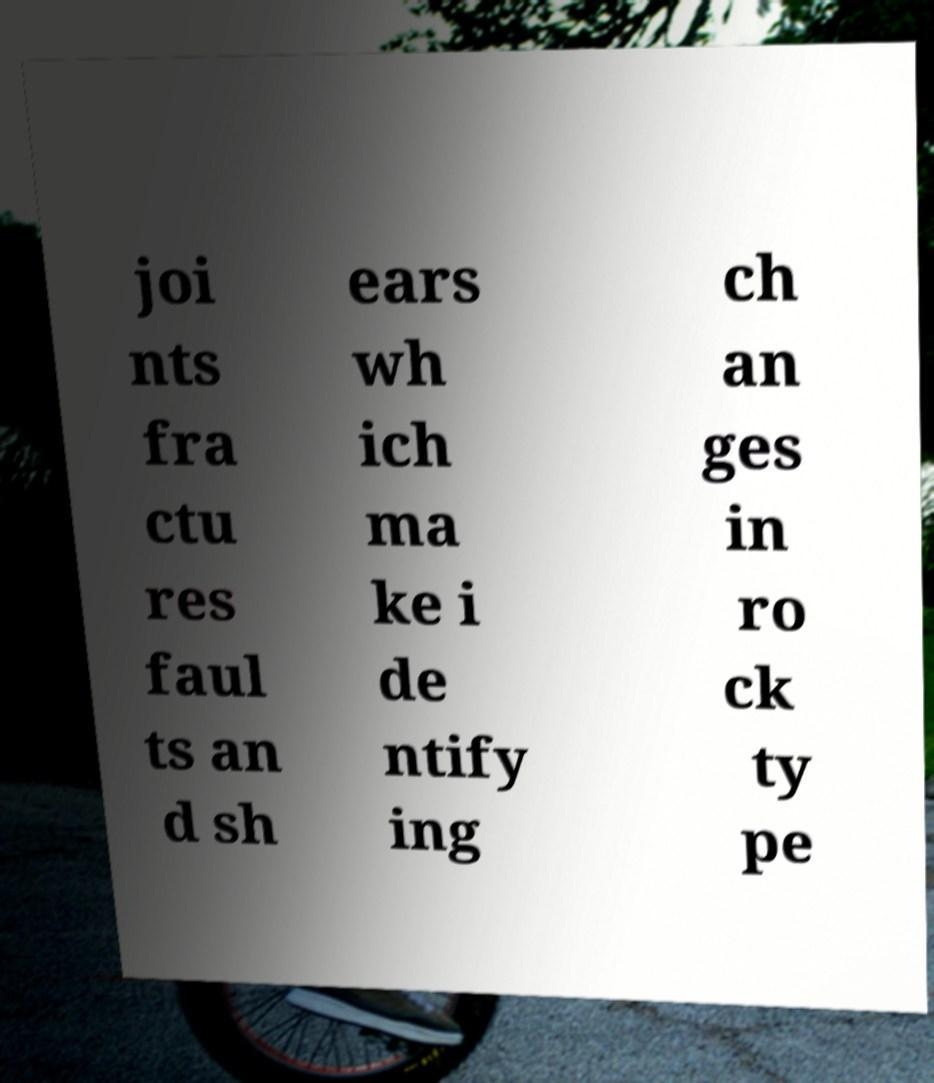For documentation purposes, I need the text within this image transcribed. Could you provide that? joi nts fra ctu res faul ts an d sh ears wh ich ma ke i de ntify ing ch an ges in ro ck ty pe 